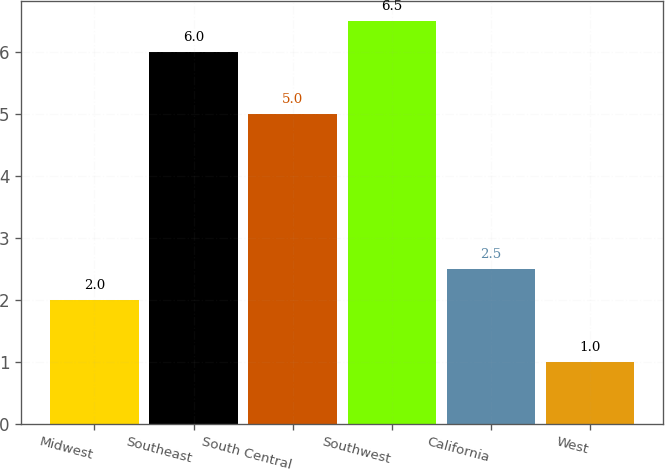Convert chart to OTSL. <chart><loc_0><loc_0><loc_500><loc_500><bar_chart><fcel>Midwest<fcel>Southeast<fcel>South Central<fcel>Southwest<fcel>California<fcel>West<nl><fcel>2<fcel>6<fcel>5<fcel>6.5<fcel>2.5<fcel>1<nl></chart> 